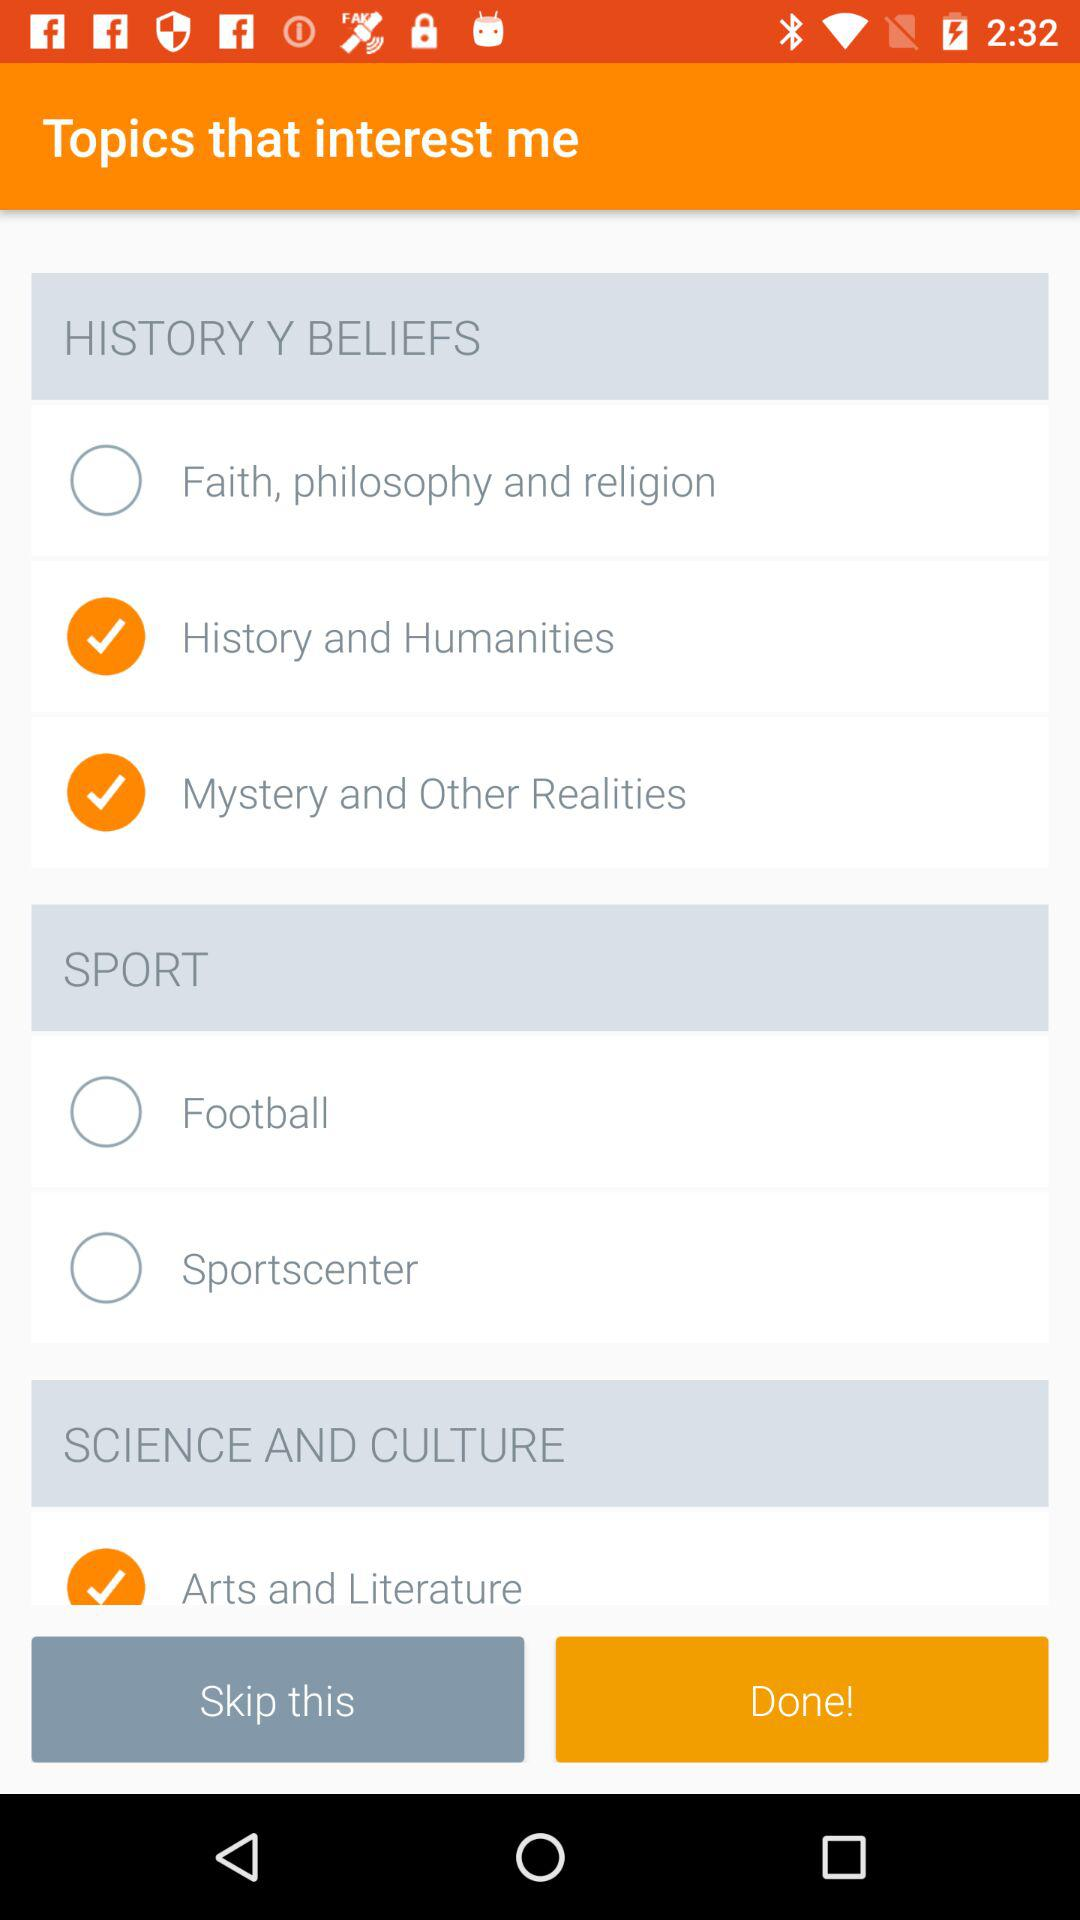What is the status of "History and Humanities"? The status is on. 